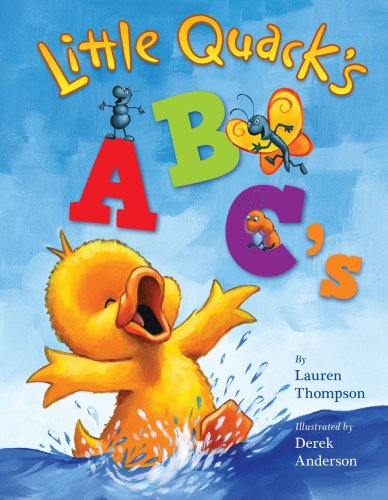Is this a journey related book? No, 'Little Quack's ABC's' is not centered around a physical journey; instead, it takes children on an educational exploration of the alphabet with fun characters. 